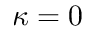<formula> <loc_0><loc_0><loc_500><loc_500>\kappa = 0</formula> 